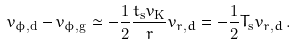<formula> <loc_0><loc_0><loc_500><loc_500>v _ { \phi , \mathrm d } - v _ { \phi , \mathrm g } \simeq - \frac { 1 } { 2 } \frac { t _ { \mathrm s } v _ { \mathrm K } } { r } v _ { r , d } = - \frac { 1 } { 2 } T _ { \mathrm s } v _ { r , d } \, .</formula> 